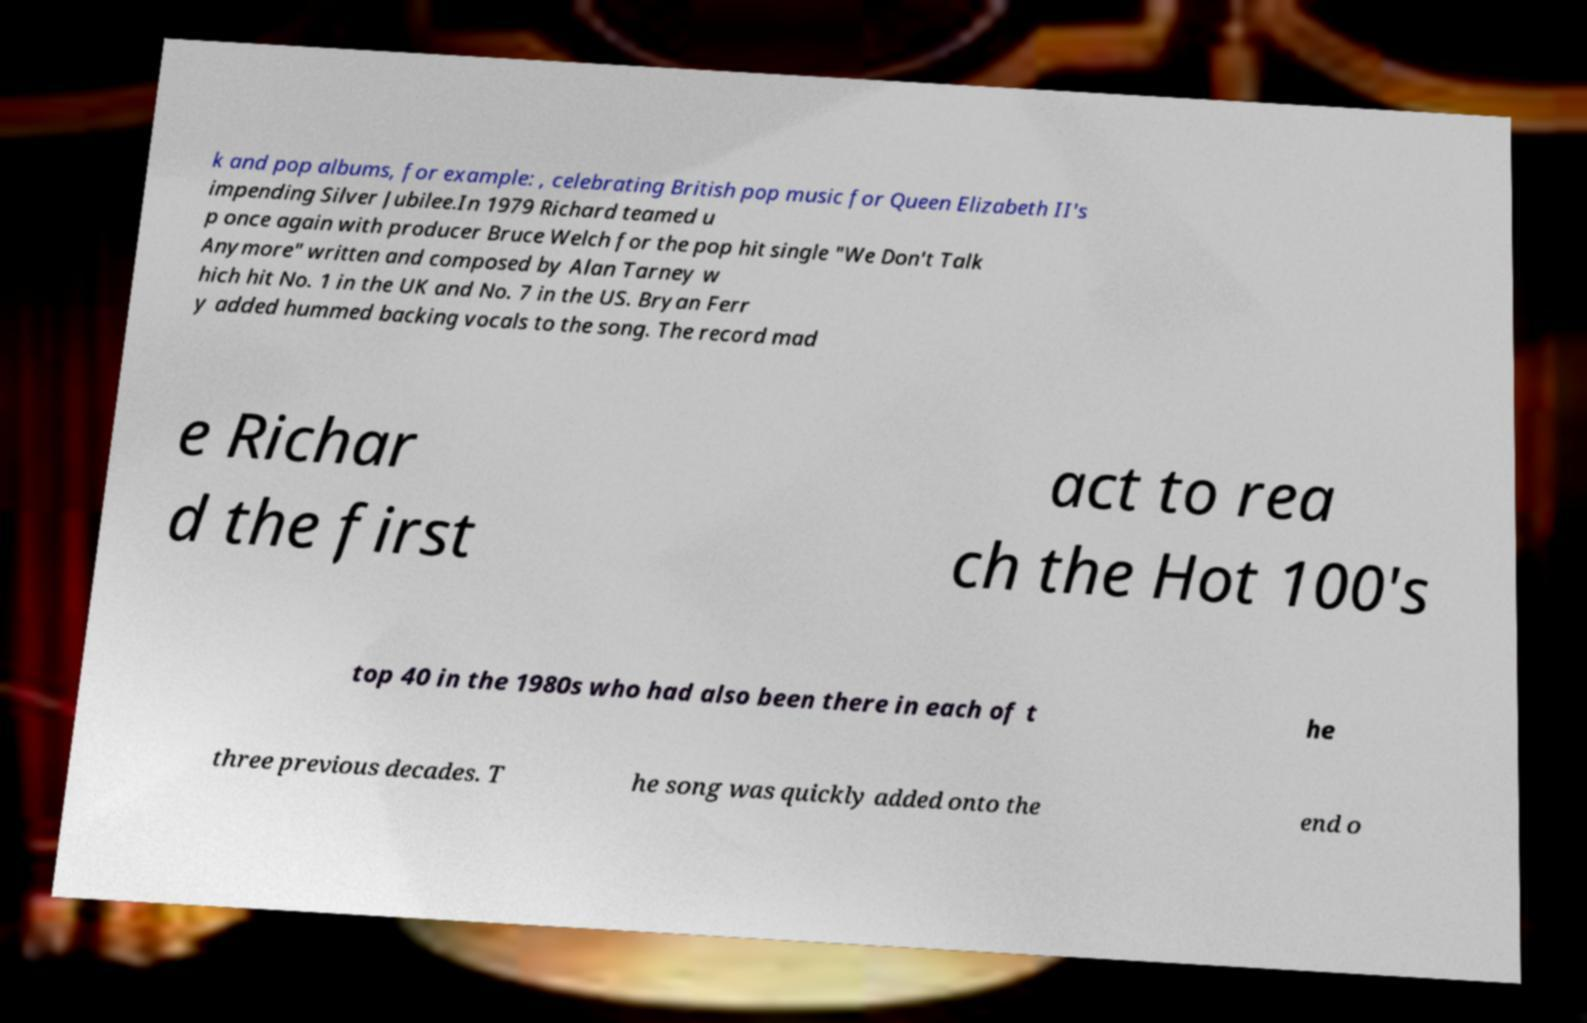I need the written content from this picture converted into text. Can you do that? k and pop albums, for example: , celebrating British pop music for Queen Elizabeth II's impending Silver Jubilee.In 1979 Richard teamed u p once again with producer Bruce Welch for the pop hit single "We Don't Talk Anymore" written and composed by Alan Tarney w hich hit No. 1 in the UK and No. 7 in the US. Bryan Ferr y added hummed backing vocals to the song. The record mad e Richar d the first act to rea ch the Hot 100's top 40 in the 1980s who had also been there in each of t he three previous decades. T he song was quickly added onto the end o 